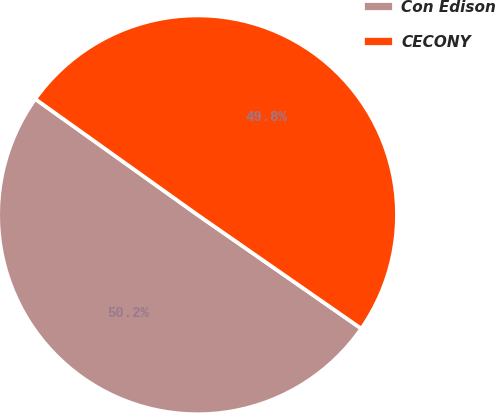Convert chart to OTSL. <chart><loc_0><loc_0><loc_500><loc_500><pie_chart><fcel>Con Edison<fcel>CECONY<nl><fcel>50.2%<fcel>49.8%<nl></chart> 